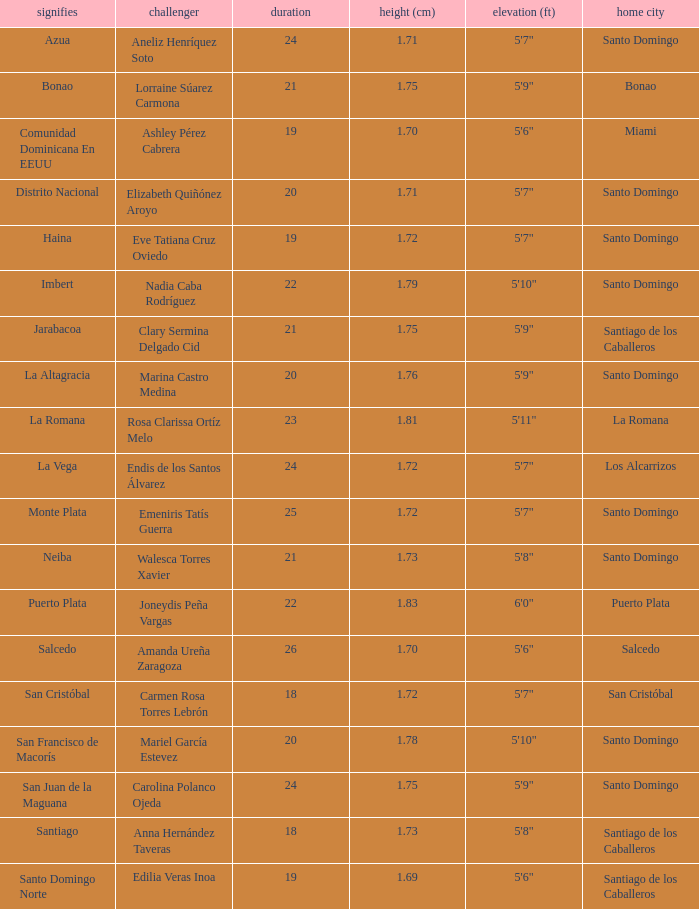Name the represents for 1.76 cm La Altagracia. 